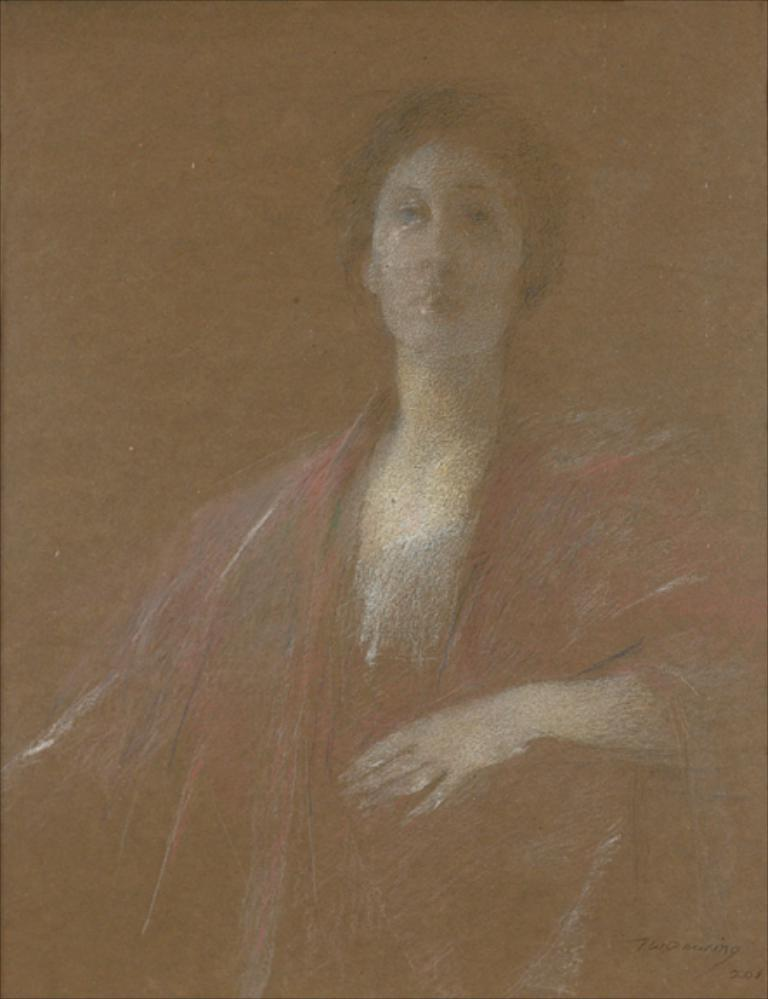Who is depicted in the painting? There is a woman in the painting. What else can be seen in the painting besides the woman? There is text in the bottom right corner of the painting. What type of wool is being spun by the woman in the painting? There is no wool or spinning depicted in the painting; it only features a woman and text in the bottom right corner. 